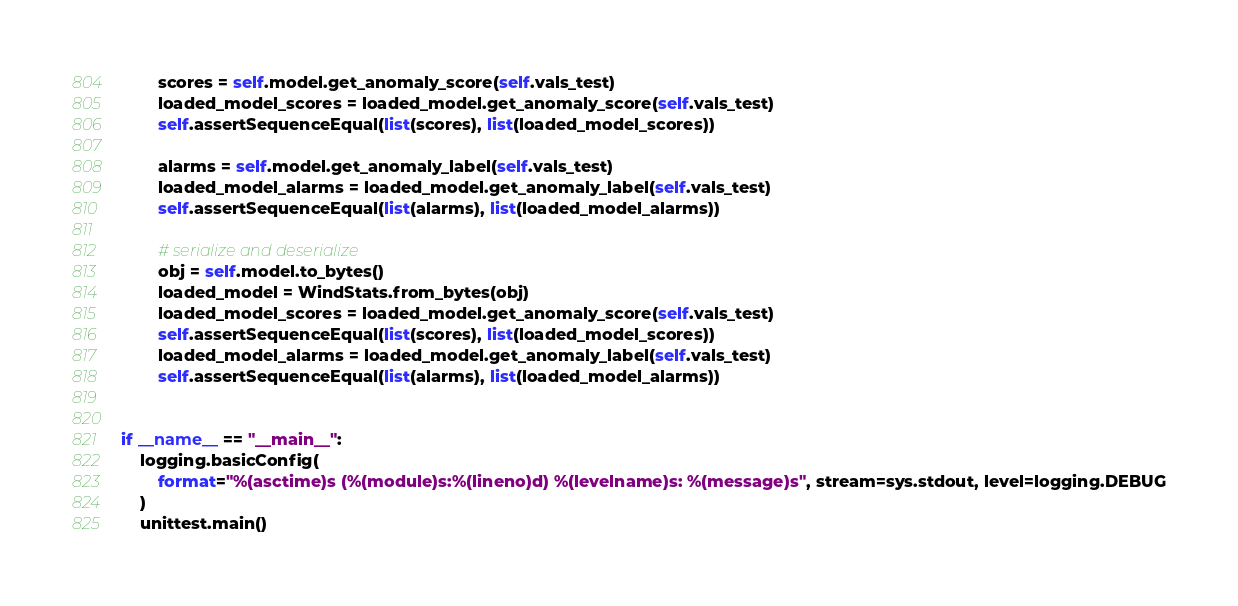<code> <loc_0><loc_0><loc_500><loc_500><_Python_>        scores = self.model.get_anomaly_score(self.vals_test)
        loaded_model_scores = loaded_model.get_anomaly_score(self.vals_test)
        self.assertSequenceEqual(list(scores), list(loaded_model_scores))

        alarms = self.model.get_anomaly_label(self.vals_test)
        loaded_model_alarms = loaded_model.get_anomaly_label(self.vals_test)
        self.assertSequenceEqual(list(alarms), list(loaded_model_alarms))

        # serialize and deserialize
        obj = self.model.to_bytes()
        loaded_model = WindStats.from_bytes(obj)
        loaded_model_scores = loaded_model.get_anomaly_score(self.vals_test)
        self.assertSequenceEqual(list(scores), list(loaded_model_scores))
        loaded_model_alarms = loaded_model.get_anomaly_label(self.vals_test)
        self.assertSequenceEqual(list(alarms), list(loaded_model_alarms))


if __name__ == "__main__":
    logging.basicConfig(
        format="%(asctime)s (%(module)s:%(lineno)d) %(levelname)s: %(message)s", stream=sys.stdout, level=logging.DEBUG
    )
    unittest.main()
</code> 